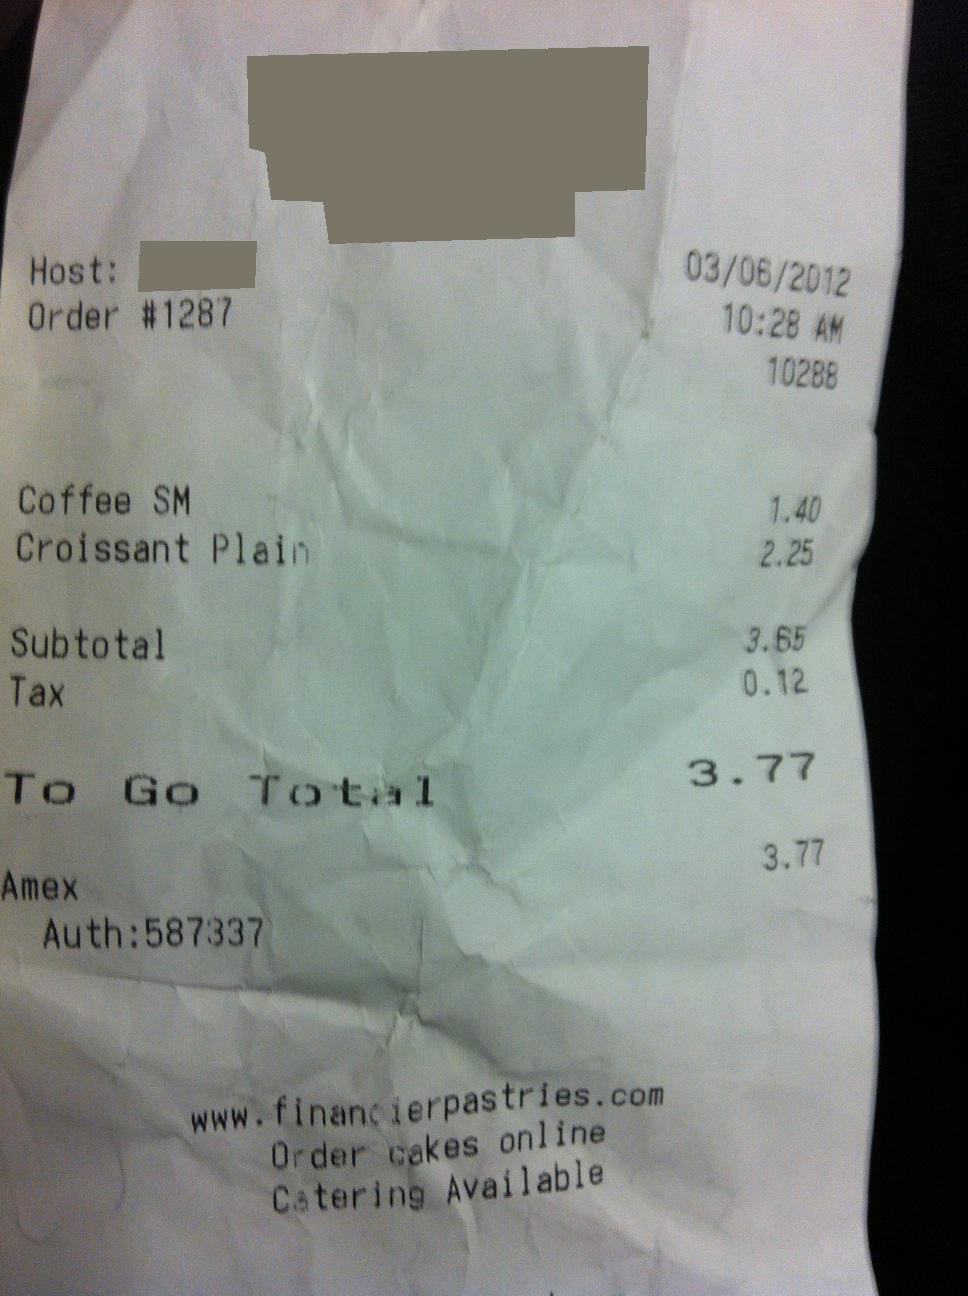Can you tell me when this purchase was made? Yes, the purchase was made on March 6th, 2012 at 10:28 AM according to the timestamp on the receipt. Is there any information about how the payment was made? The payment was made using an American Express credit card, as indicated by 'Amex' on the receipt, and the authorization number for the transaction is 587337. 